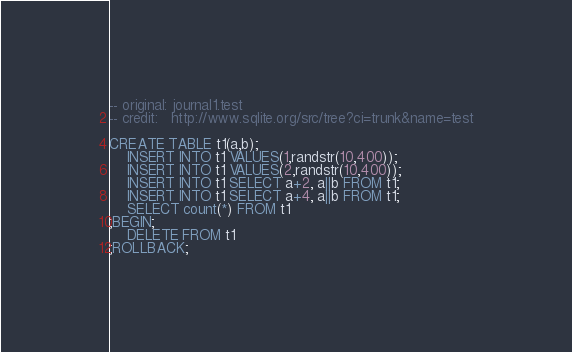<code> <loc_0><loc_0><loc_500><loc_500><_SQL_>-- original: journal1.test
-- credit:   http://www.sqlite.org/src/tree?ci=trunk&name=test

CREATE TABLE t1(a,b);
    INSERT INTO t1 VALUES(1,randstr(10,400));
    INSERT INTO t1 VALUES(2,randstr(10,400));
    INSERT INTO t1 SELECT a+2, a||b FROM t1;
    INSERT INTO t1 SELECT a+4, a||b FROM t1;
    SELECT count(*) FROM t1
;BEGIN;
    DELETE FROM t1
;ROLLBACK;</code> 